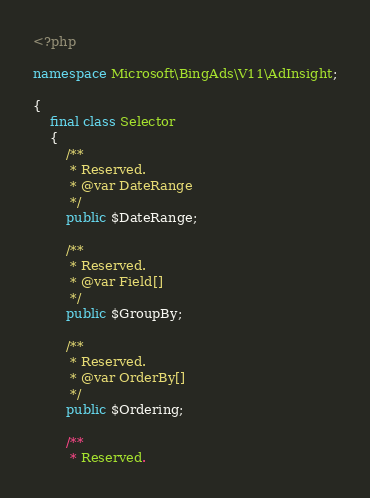<code> <loc_0><loc_0><loc_500><loc_500><_PHP_><?php

namespace Microsoft\BingAds\V11\AdInsight;

{
    final class Selector
    {
        /**
         * Reserved.
         * @var DateRange
         */
        public $DateRange;

        /**
         * Reserved.
         * @var Field[]
         */
        public $GroupBy;

        /**
         * Reserved.
         * @var OrderBy[]
         */
        public $Ordering;

        /**
         * Reserved.</code> 